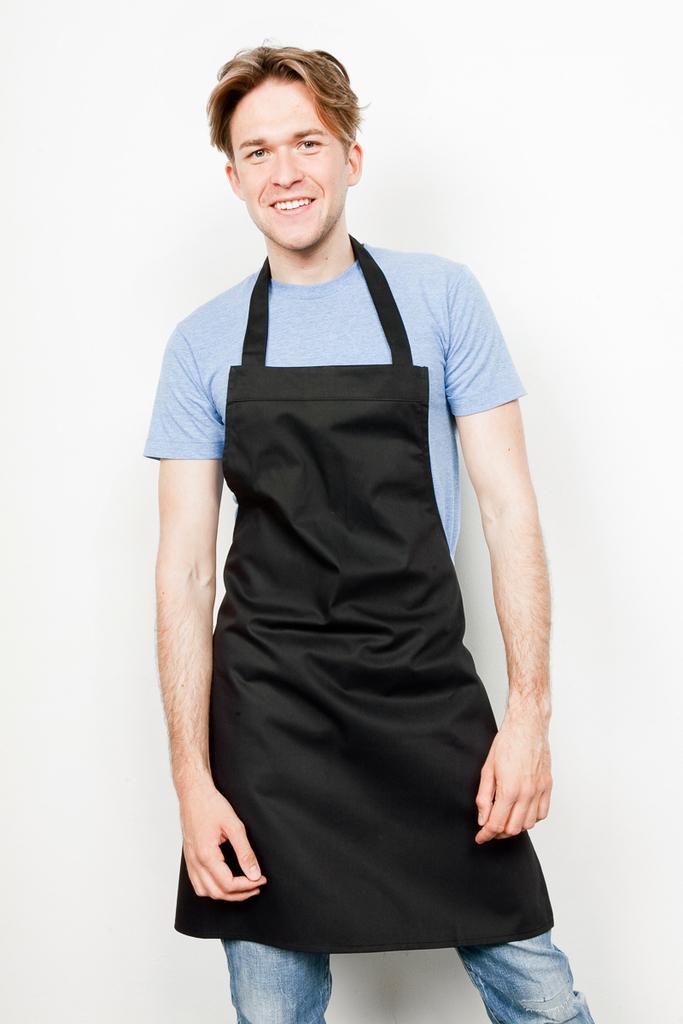Please provide a concise description of this image. In this image, we can see a man wearing an apron and standing. He is smiling. In the background, we can see the white color. 